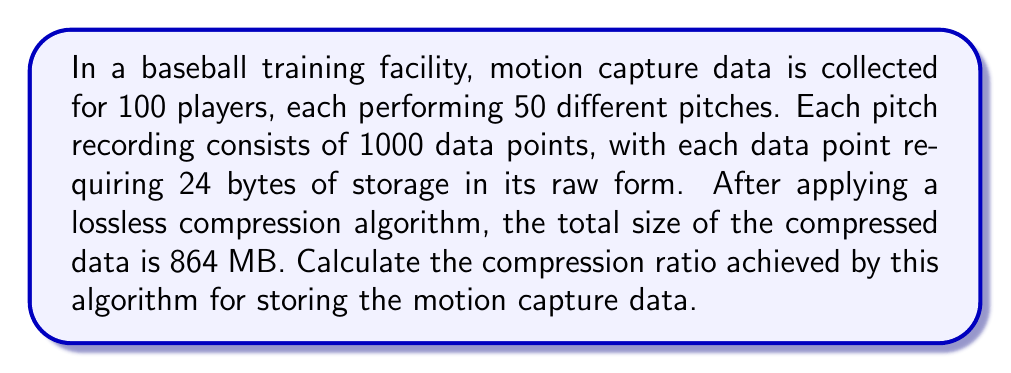Can you solve this math problem? To calculate the compression ratio, we need to follow these steps:

1. Calculate the total size of the uncompressed data:
   - Number of players: 100
   - Number of pitches per player: 50
   - Number of data points per pitch: 1000
   - Size of each data point: 24 bytes

   Total uncompressed size = $100 \times 50 \times 1000 \times 24$ bytes
                            = $120,000,000$ bytes
                            = $120,000,000 \div 1,048,576$ MB (1 MB = 1,048,576 bytes)
                            = $114.44$ MB

2. Given compressed size: 864 MB

3. Calculate the compression ratio:
   Compression ratio = $\frac{\text{Uncompressed size}}{\text{Compressed size}}$

   $$ \text{Compression ratio} = \frac{120,000,000}{864 \times 1,048,576} $$

4. Simplify and calculate:
   $$ \text{Compression ratio} = \frac{120,000,000}{905,969,664} \approx 0.1324 $$

5. To express as a ratio, we can invert this value:
   $$ \text{Compression ratio} \approx \frac{1}{0.1324} \approx 7.55:1 $$

This means that for every 7.55 bytes of uncompressed data, we only need 1 byte of compressed data.
Answer: The compression ratio achieved by the algorithm is approximately 7.55:1. 